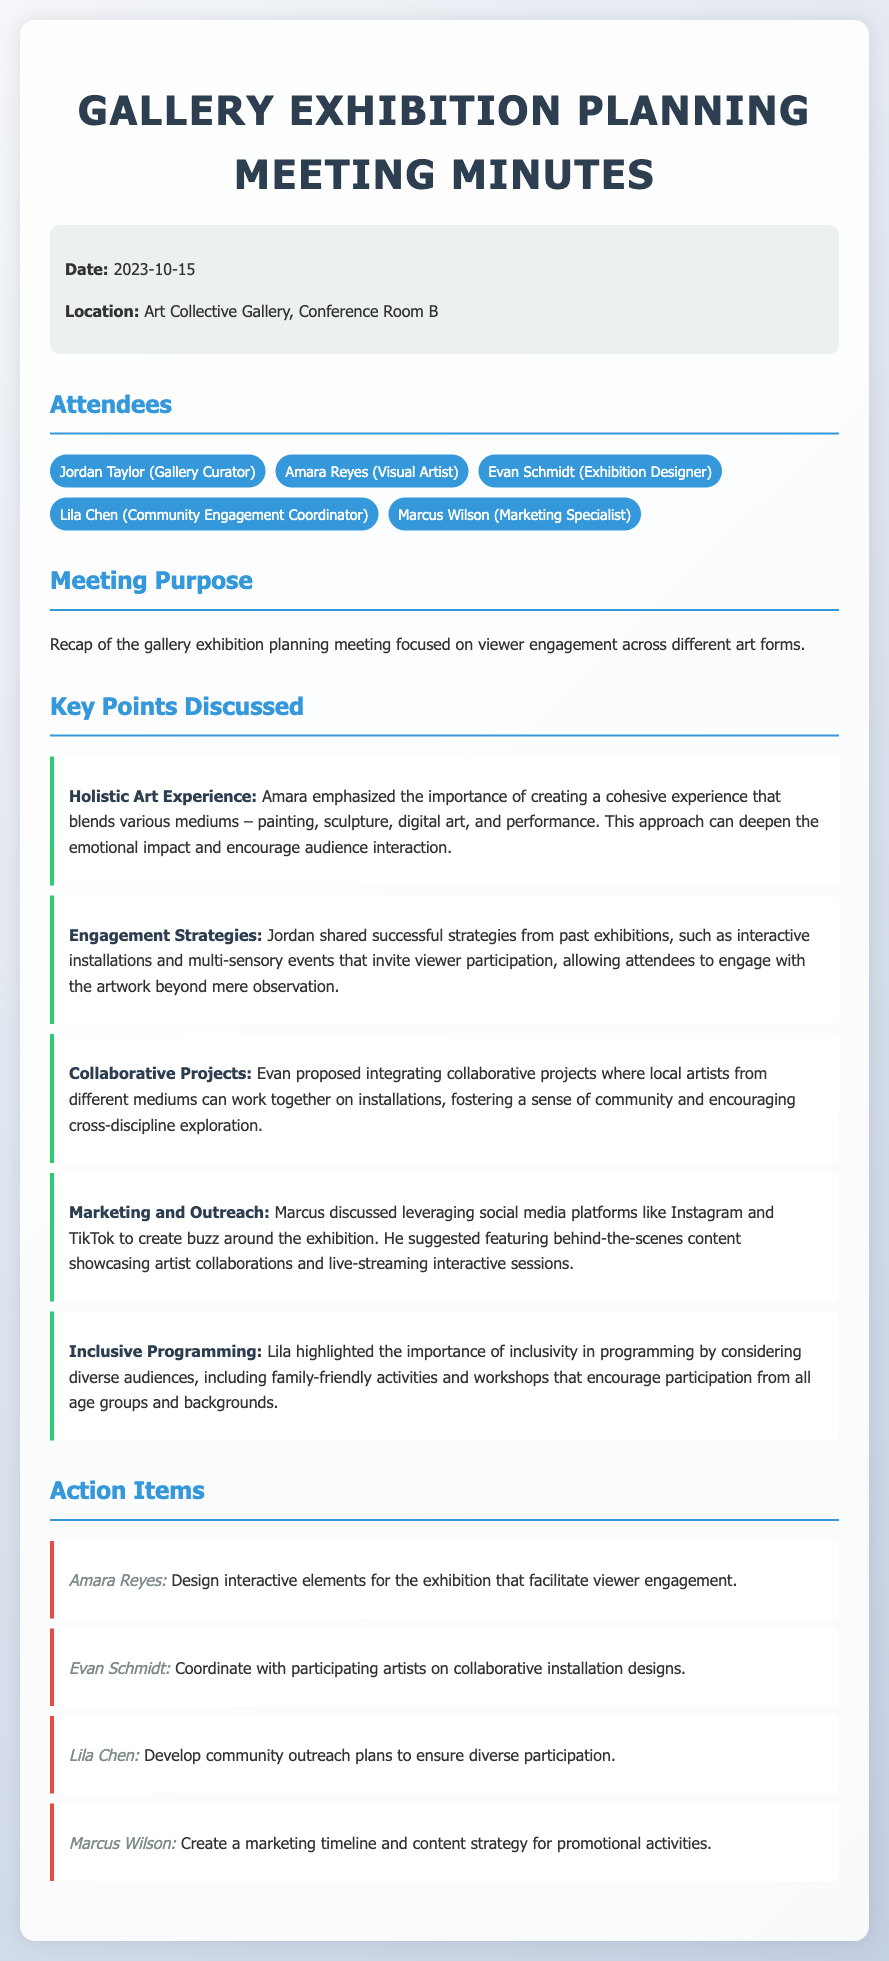What was the date of the meeting? The date of the meeting is explicitly mentioned in the document, which states the meeting took place on "2023-10-15."
Answer: 2023-10-15 Who emphasized the holistic art experience? The document notes that Amara emphasized the importance of creating a holistic art experience.
Answer: Amara What is one engagement strategy shared by Jordan? Jordan shared successful strategies from past exhibitions, including "interactive installations."
Answer: interactive installations Which role is responsible for designing interactive elements? The action items specify that Amara Reyes is responsible for designing interactive elements for the exhibition.
Answer: Amara Reyes What did Lila highlight regarding programming? Lila highlighted the importance of "inclusivity" in programming for the exhibition.
Answer: inclusivity How many attendees are listed in the meeting minutes? The document includes a list of five attendees at the meeting.
Answer: five What is Marcus's responsibility in the action items? Marcus Wilson's action item involves creating a "marketing timeline and content strategy."
Answer: marketing timeline and content strategy What type of projects did Evan propose? Evan proposed integrating "collaborative projects" involving local artists.
Answer: collaborative projects What is the purpose of the meeting? The purpose as stated in the document is to recap the gallery exhibition planning meeting focusing on viewer engagement.
Answer: viewer engagement 